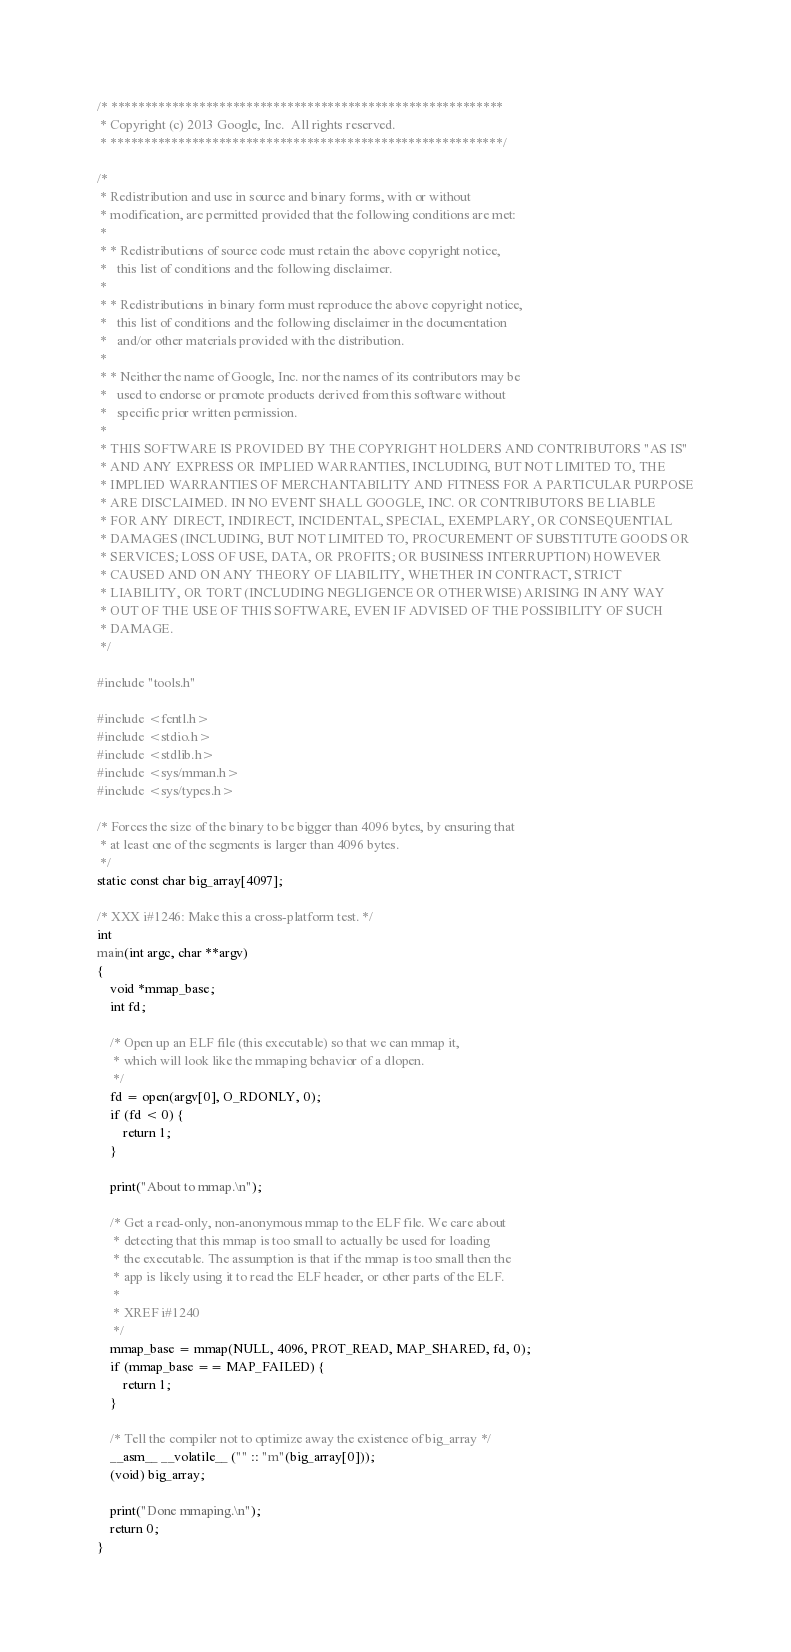Convert code to text. <code><loc_0><loc_0><loc_500><loc_500><_C_>/* **********************************************************
 * Copyright (c) 2013 Google, Inc.  All rights reserved.
 * **********************************************************/

/*
 * Redistribution and use in source and binary forms, with or without
 * modification, are permitted provided that the following conditions are met:
 *
 * * Redistributions of source code must retain the above copyright notice,
 *   this list of conditions and the following disclaimer.
 *
 * * Redistributions in binary form must reproduce the above copyright notice,
 *   this list of conditions and the following disclaimer in the documentation
 *   and/or other materials provided with the distribution.
 *
 * * Neither the name of Google, Inc. nor the names of its contributors may be
 *   used to endorse or promote products derived from this software without
 *   specific prior written permission.
 *
 * THIS SOFTWARE IS PROVIDED BY THE COPYRIGHT HOLDERS AND CONTRIBUTORS "AS IS"
 * AND ANY EXPRESS OR IMPLIED WARRANTIES, INCLUDING, BUT NOT LIMITED TO, THE
 * IMPLIED WARRANTIES OF MERCHANTABILITY AND FITNESS FOR A PARTICULAR PURPOSE
 * ARE DISCLAIMED. IN NO EVENT SHALL GOOGLE, INC. OR CONTRIBUTORS BE LIABLE
 * FOR ANY DIRECT, INDIRECT, INCIDENTAL, SPECIAL, EXEMPLARY, OR CONSEQUENTIAL
 * DAMAGES (INCLUDING, BUT NOT LIMITED TO, PROCUREMENT OF SUBSTITUTE GOODS OR
 * SERVICES; LOSS OF USE, DATA, OR PROFITS; OR BUSINESS INTERRUPTION) HOWEVER
 * CAUSED AND ON ANY THEORY OF LIABILITY, WHETHER IN CONTRACT, STRICT
 * LIABILITY, OR TORT (INCLUDING NEGLIGENCE OR OTHERWISE) ARISING IN ANY WAY
 * OUT OF THE USE OF THIS SOFTWARE, EVEN IF ADVISED OF THE POSSIBILITY OF SUCH
 * DAMAGE.
 */

#include "tools.h"

#include <fcntl.h>
#include <stdio.h>
#include <stdlib.h>
#include <sys/mman.h>
#include <sys/types.h>

/* Forces the size of the binary to be bigger than 4096 bytes, by ensuring that
 * at least one of the segments is larger than 4096 bytes.
 */
static const char big_array[4097];

/* XXX i#1246: Make this a cross-platform test. */
int
main(int argc, char **argv)
{
    void *mmap_base;
    int fd;

    /* Open up an ELF file (this executable) so that we can mmap it,
     * which will look like the mmaping behavior of a dlopen.
     */
    fd = open(argv[0], O_RDONLY, 0);
    if (fd < 0) {
        return 1;
    }

    print("About to mmap.\n");

    /* Get a read-only, non-anonymous mmap to the ELF file. We care about
     * detecting that this mmap is too small to actually be used for loading
     * the executable. The assumption is that if the mmap is too small then the
     * app is likely using it to read the ELF header, or other parts of the ELF.
     *
     * XREF i#1240
     */
    mmap_base = mmap(NULL, 4096, PROT_READ, MAP_SHARED, fd, 0);
    if (mmap_base == MAP_FAILED) {
        return 1;
    }

    /* Tell the compiler not to optimize away the existence of big_array */
    __asm__ __volatile__ ("" :: "m"(big_array[0]));
    (void) big_array;

    print("Done mmaping.\n");
    return 0;
}
</code> 